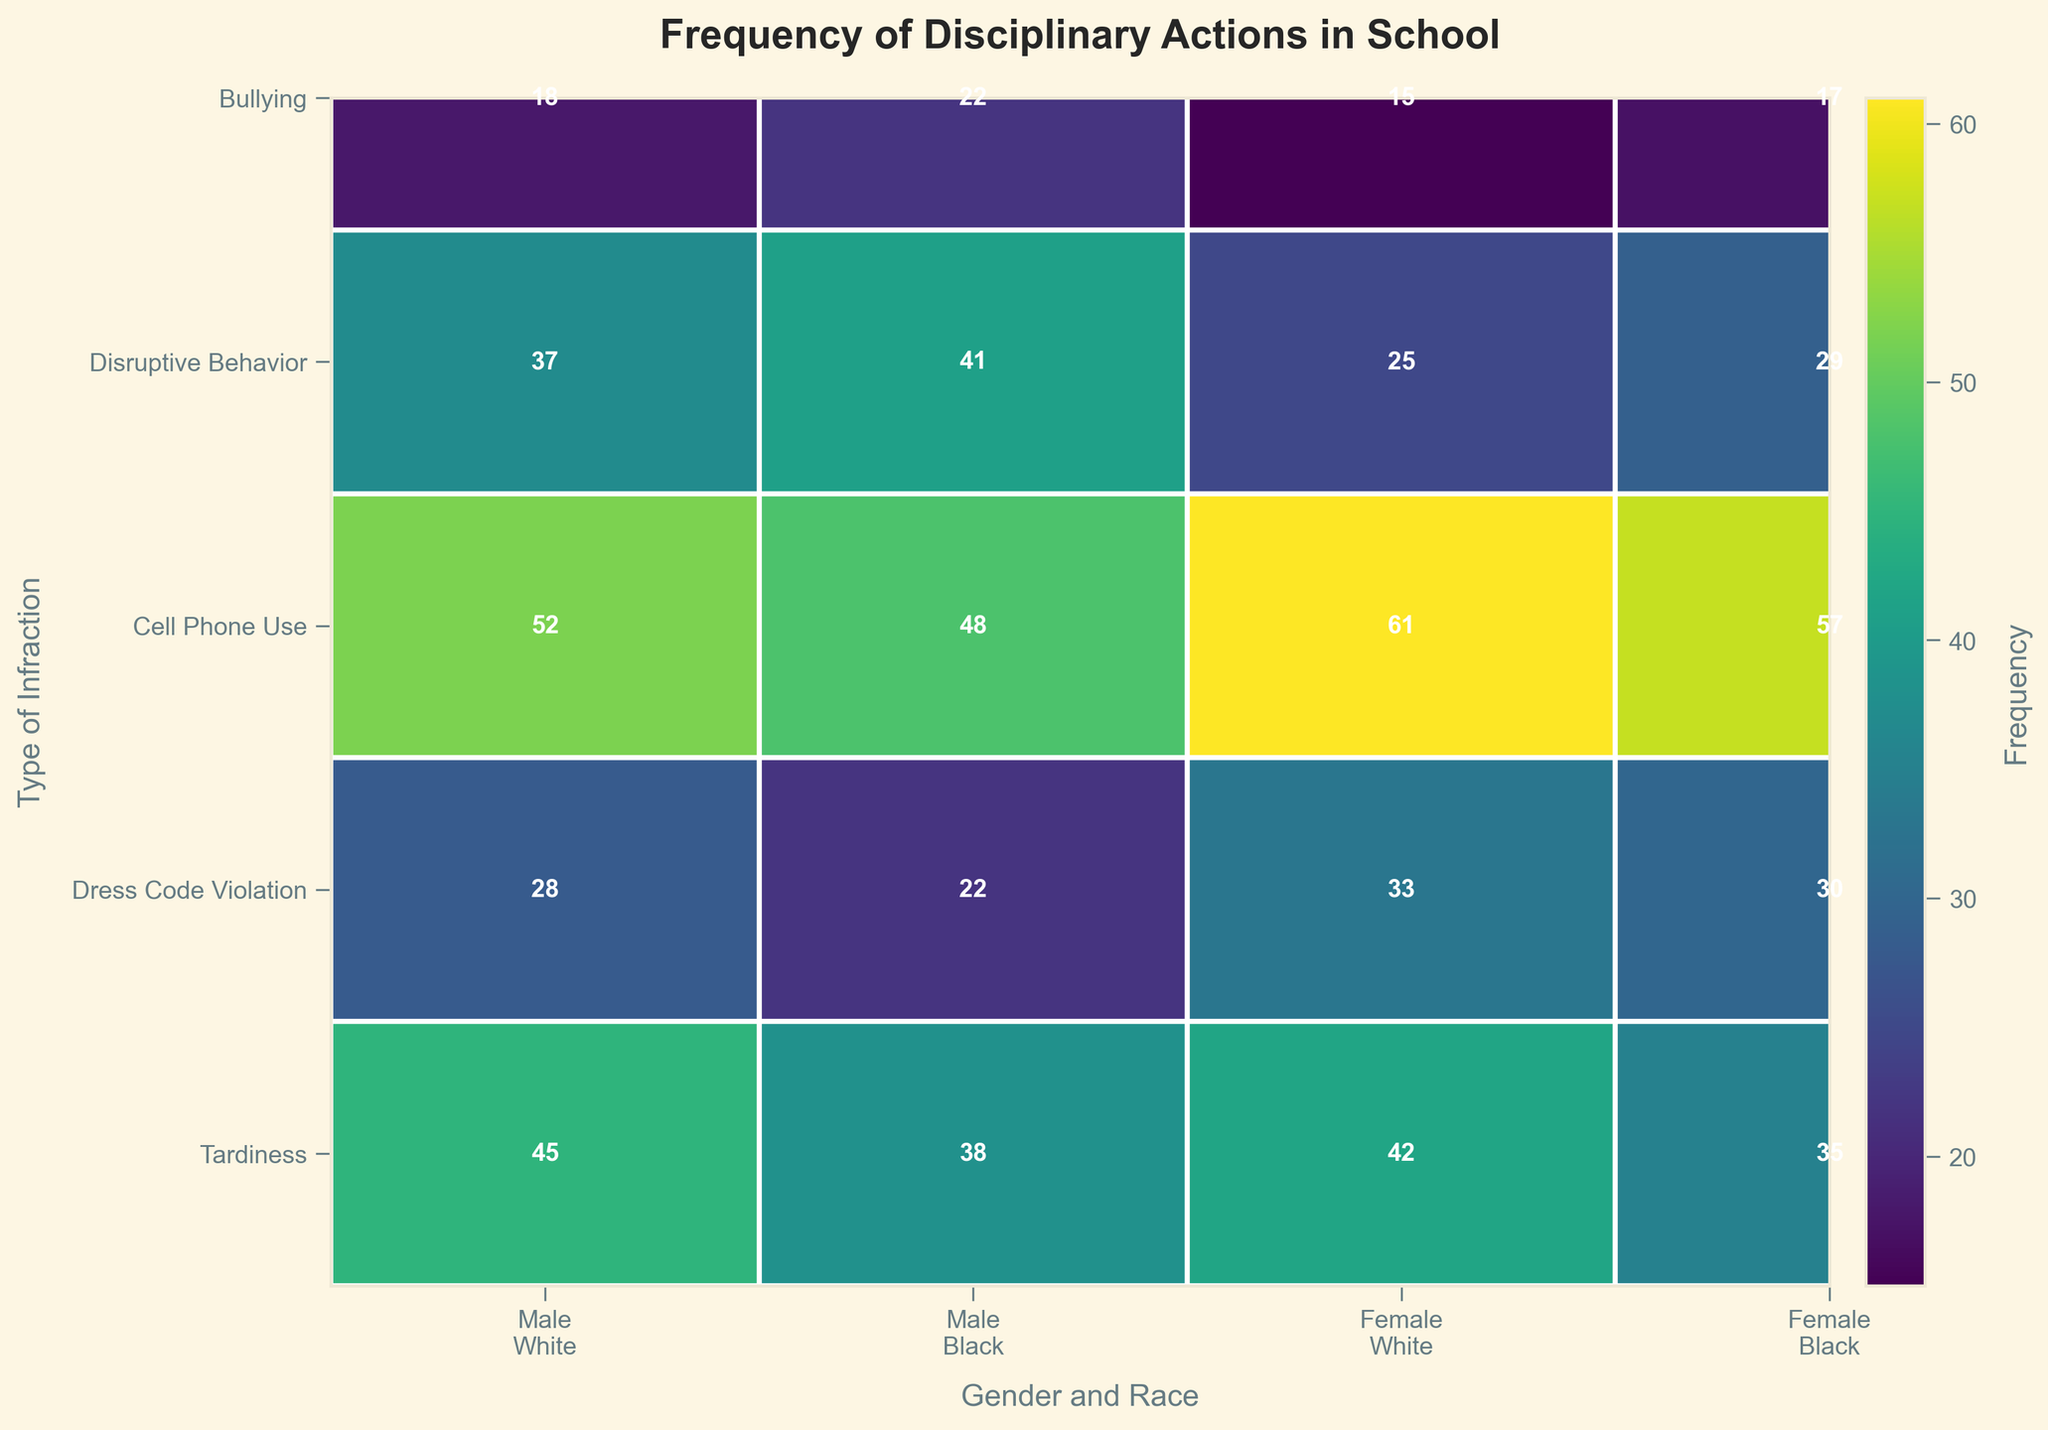What's the title of the figure? The title is located at the top of the figure and summarizes the main content conveyed by the data visualization.
Answer: Frequency of Disciplinary Actions in School Which type of infraction among female White students has the highest frequency? Look for the sections within the row corresponding to "female White" and compare the frequency values for each infraction.
Answer: Cell Phone Use What is the frequency of disruptive behavior among male Black students? Locate the cell that corresponds to "Disruptive Behavior" in the row and "male Black" in the column, and read the frequency value displayed inside.
Answer: 41 Compare the frequency of bullying between female White students and male White students. Who has a higher frequency? Look for the cells corresponding to "Bullying" in the rows of "female White" and "male White," then compare the frequency values.
Answer: Male White students What is the sum of frequencies for dress code violation among Black students, regardless of gender? Sum the values of "Dress Code Violation" for both male Black and female Black students.
Answer: 22 + 30 = 52 Which gender and race combination shows the lowest frequency for bullying? Look at the "Bullying" row and compare the frequencies for each gender-race combination to determine the lowest value.
Answer: Female White How does the frequency of tardiness compare between male Black students and female Black students? Compare the frequency values of "Tardiness" for male Black and female Black students by checking the respective cells.
Answer: Male Black students have a slightly higher frequency Calculate the average frequency of cell phone use across all groups. Sum the frequencies of "Cell Phone Use" for all gender-race combinations and divide by the number of groups (4).
Answer: (52 + 48 + 61 + 57) / 4 = 54.5 Which infraction has a higher frequency among female Black students: disruptive behavior or cell phone use? Compare the frequency values of "Disruptive Behavior" and "Cell Phone Use" for female Black students by checking the respective cells.
Answer: Cell Phone Use Identify the cell with the highest frequency overall and state its category and demographic. Visually scan all cells to find the highest frequency value and note the corresponding infraction, gender, and race.
Answer: Cell Phone Use, Female, White 